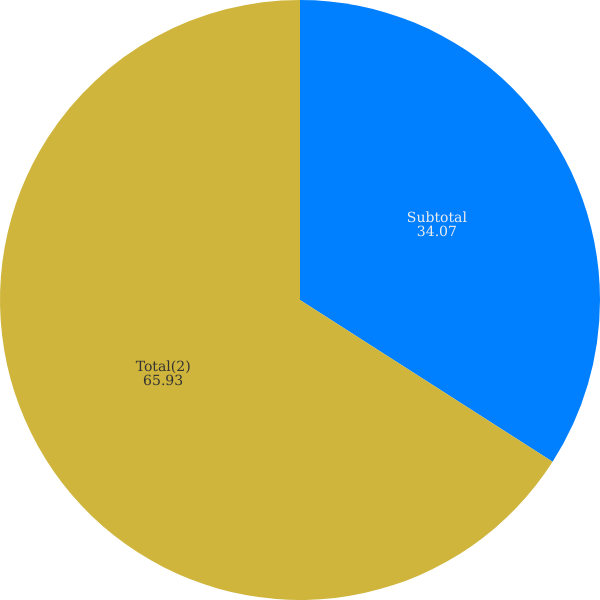<chart> <loc_0><loc_0><loc_500><loc_500><pie_chart><fcel>Subtotal<fcel>Total(2)<nl><fcel>34.07%<fcel>65.93%<nl></chart> 